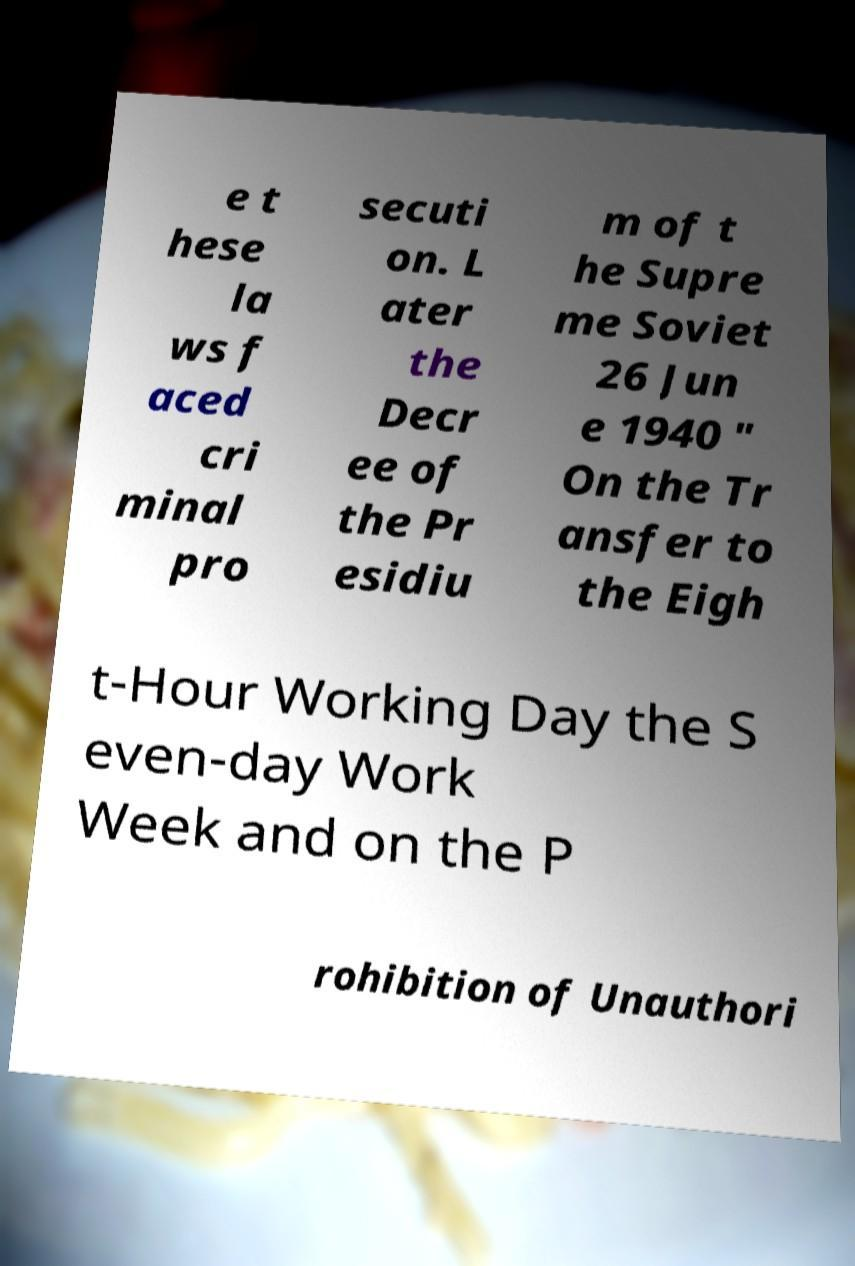Please read and relay the text visible in this image. What does it say? e t hese la ws f aced cri minal pro secuti on. L ater the Decr ee of the Pr esidiu m of t he Supre me Soviet 26 Jun e 1940 " On the Tr ansfer to the Eigh t-Hour Working Day the S even-day Work Week and on the P rohibition of Unauthori 